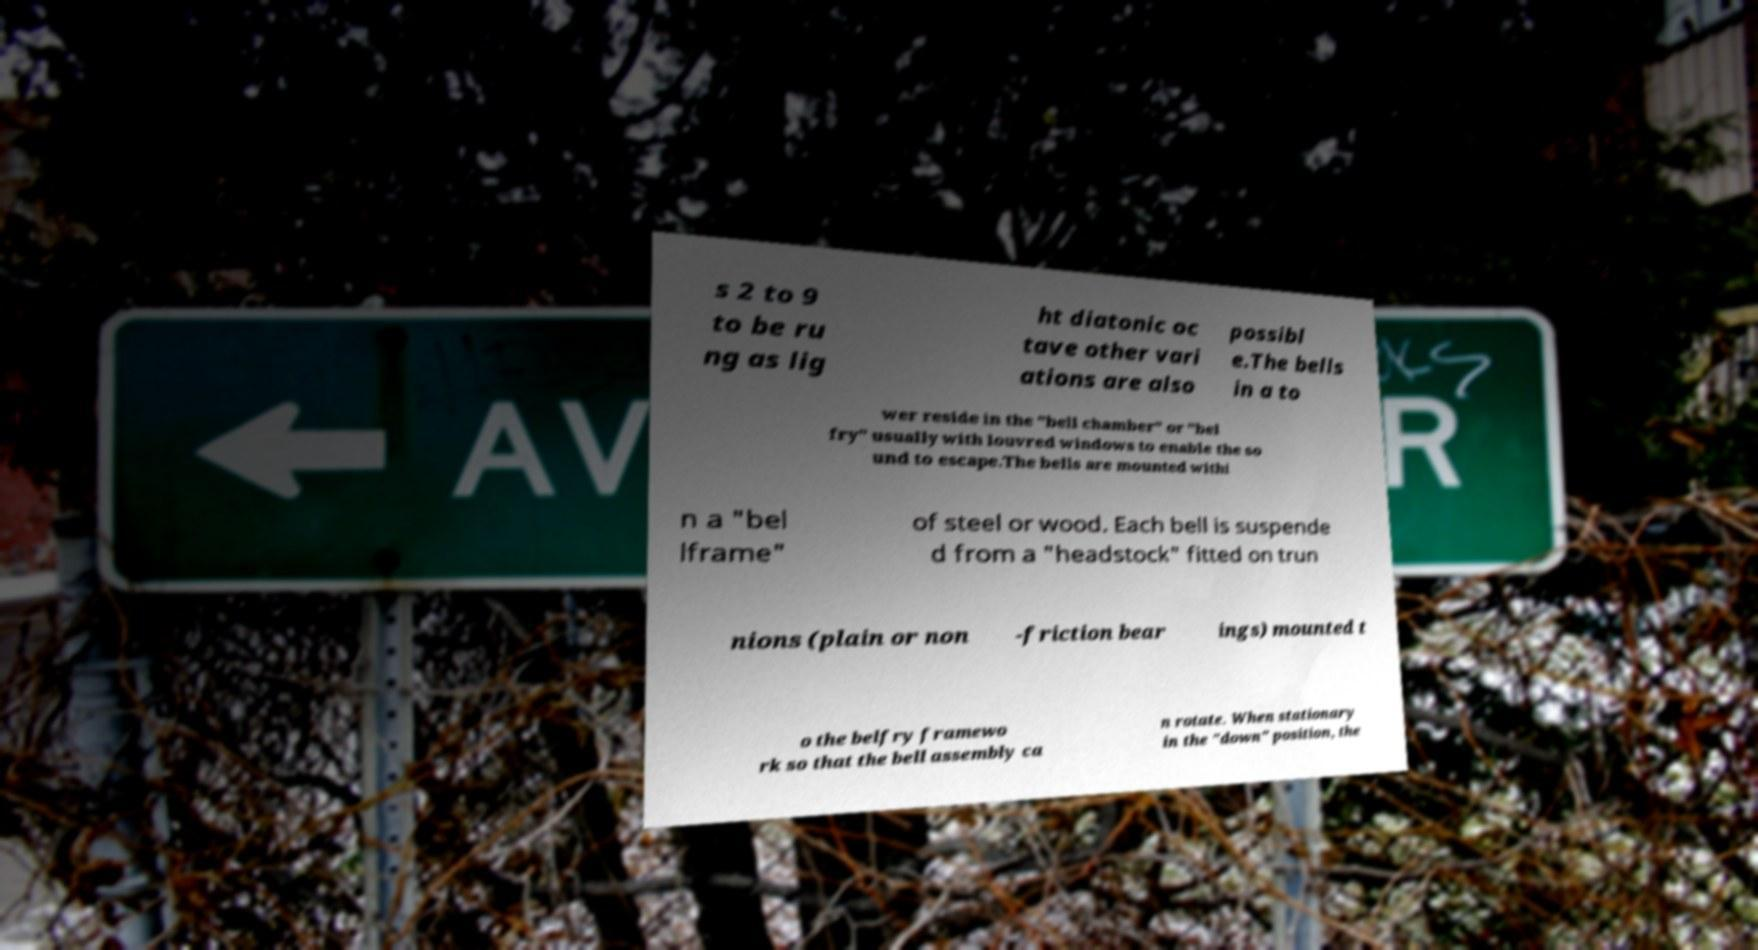What messages or text are displayed in this image? I need them in a readable, typed format. s 2 to 9 to be ru ng as lig ht diatonic oc tave other vari ations are also possibl e.The bells in a to wer reside in the "bell chamber" or "bel fry" usually with louvred windows to enable the so und to escape.The bells are mounted withi n a "bel lframe" of steel or wood. Each bell is suspende d from a "headstock" fitted on trun nions (plain or non -friction bear ings) mounted t o the belfry framewo rk so that the bell assembly ca n rotate. When stationary in the "down" position, the 